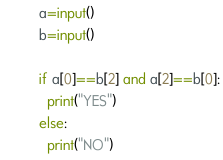Convert code to text. <code><loc_0><loc_0><loc_500><loc_500><_Python_>a=input()
b=input()

if a[0]==b[2] and a[2]==b[0]:
  print("YES")
else:
  print("NO")</code> 